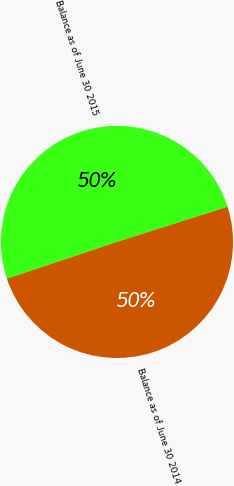Convert chart. <chart><loc_0><loc_0><loc_500><loc_500><pie_chart><fcel>Balance as of June 30 2015<fcel>Balance as of June 30 2014<nl><fcel>50.23%<fcel>49.77%<nl></chart> 